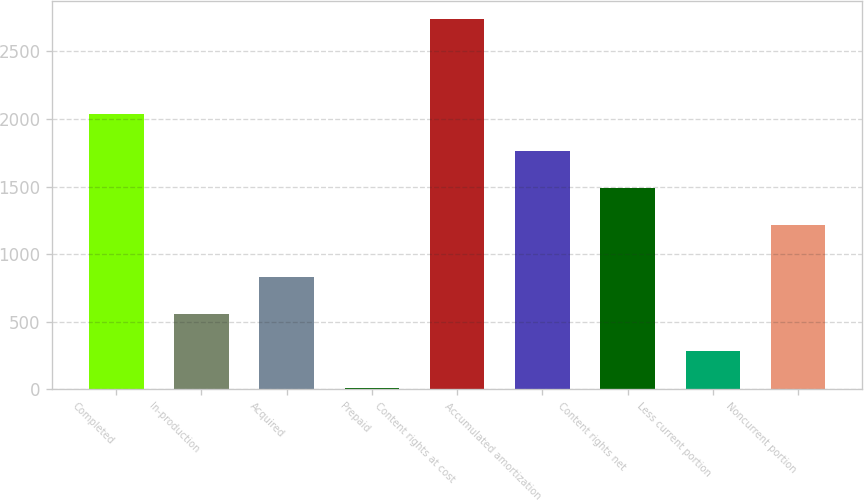Convert chart. <chart><loc_0><loc_0><loc_500><loc_500><bar_chart><fcel>Completed<fcel>In-production<fcel>Acquired<fcel>Prepaid<fcel>Content rights at cost<fcel>Accumulated amortization<fcel>Content rights net<fcel>Less current portion<fcel>Noncurrent portion<nl><fcel>2033.9<fcel>557.6<fcel>829.9<fcel>13<fcel>2736<fcel>1761.6<fcel>1489.3<fcel>285.3<fcel>1217<nl></chart> 